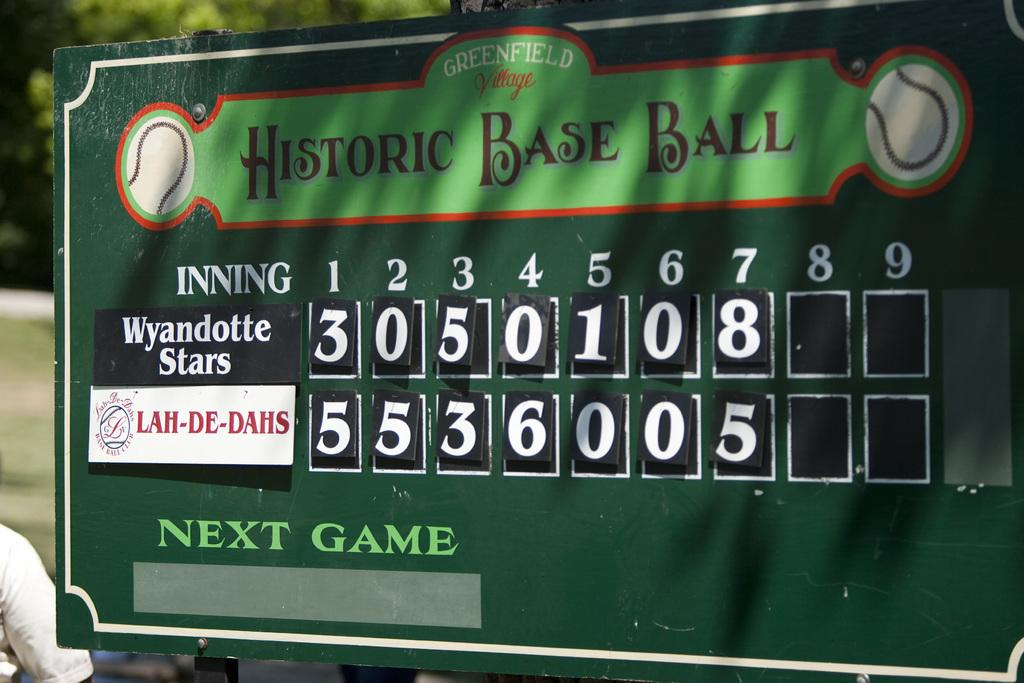<image>
Present a compact description of the photo's key features. A green scoreboard of a baseball game showing a play between the Wyandotte Stars and the Lah-De-Dahs. 